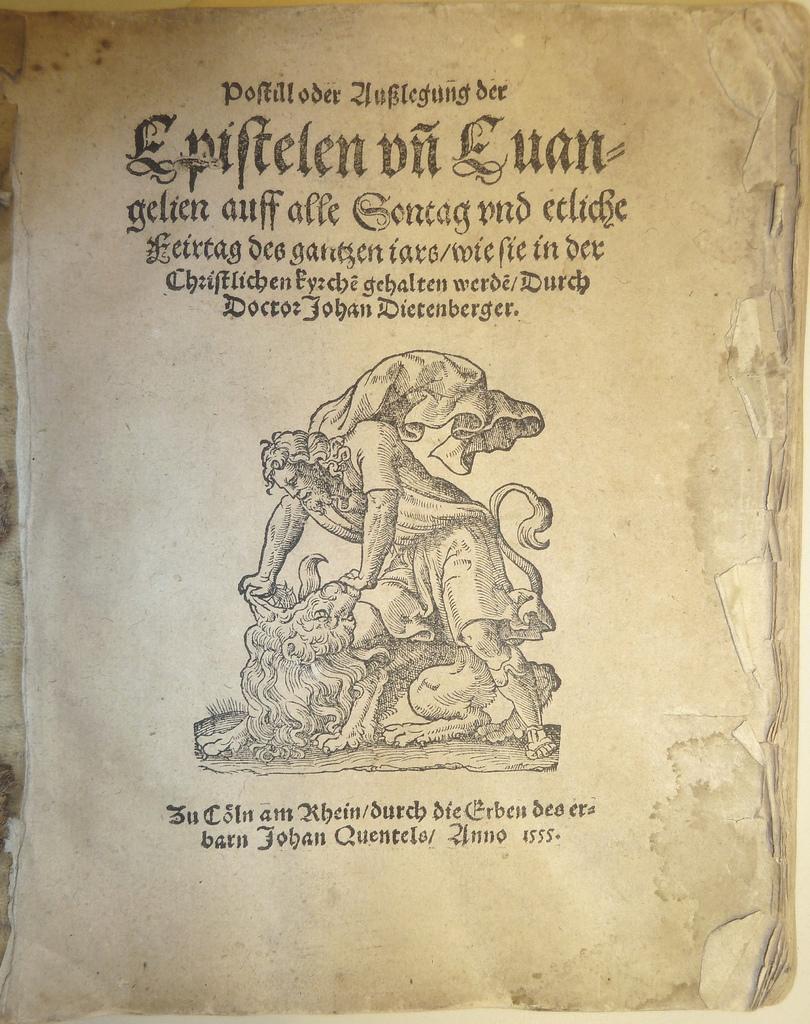Can you describe this image briefly? In this image, this looks like a paper. I can see the picture of a person and an animal. These are the letters on the paper. 